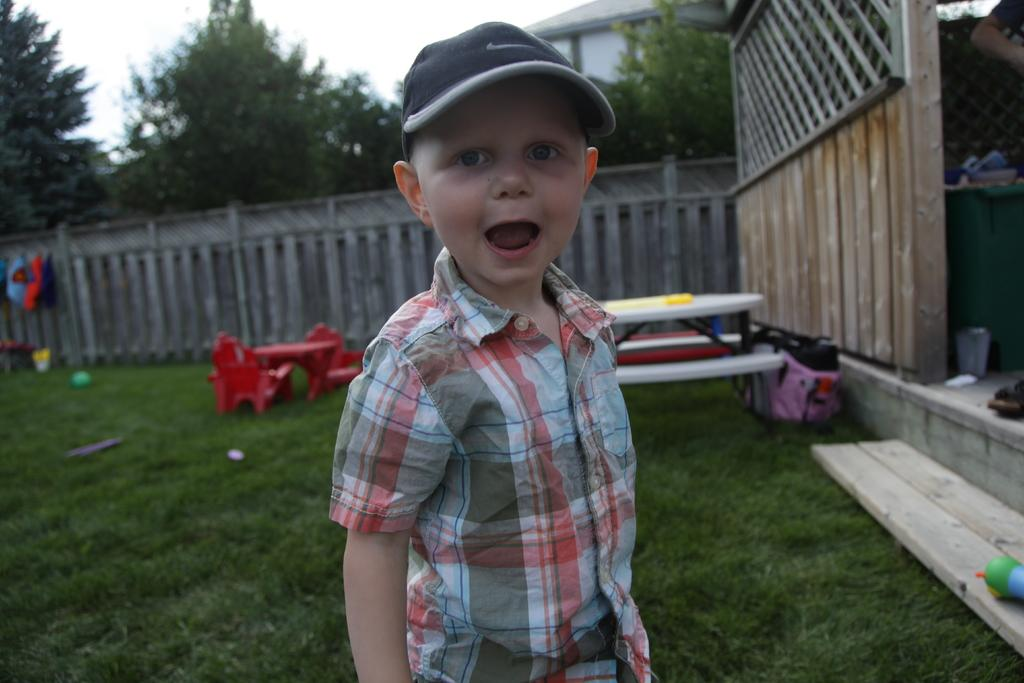Who is the main subject in the image? There is a boy in the image. What can be seen in the background of the image? In the background of the image, there is a fence, grass, a building, trees, and some unspecified objects. What is visible in the sky in the image? The sky is visible in the background of the image. What types of toys are the children playing with in the image? There are no children or toys present in the image; it features a boy and various background elements. 